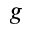Convert formula to latex. <formula><loc_0><loc_0><loc_500><loc_500>g</formula> 